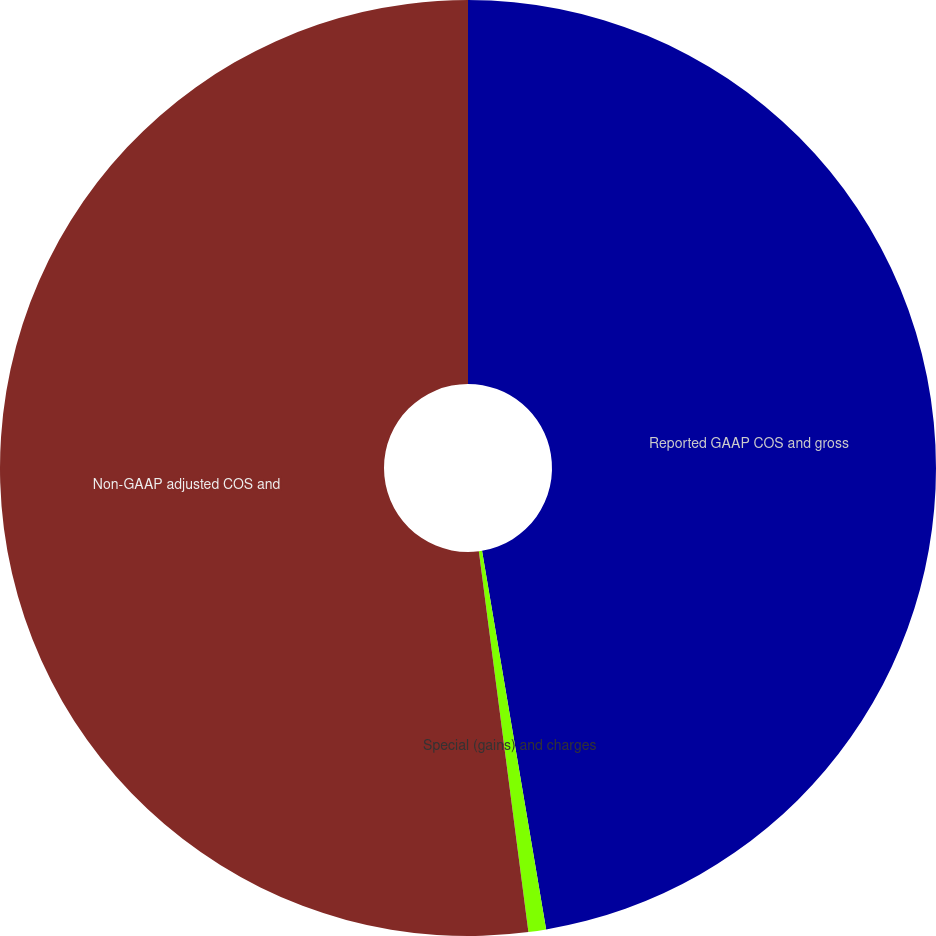Convert chart to OTSL. <chart><loc_0><loc_0><loc_500><loc_500><pie_chart><fcel>Reported GAAP COS and gross<fcel>Special (gains) and charges<fcel>Non-GAAP adjusted COS and<nl><fcel>47.33%<fcel>0.61%<fcel>52.06%<nl></chart> 